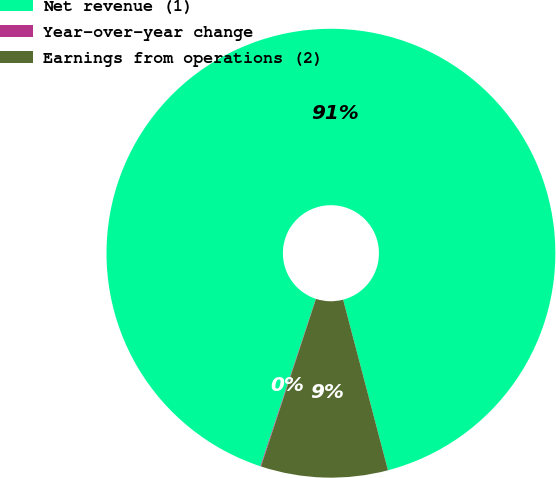Convert chart to OTSL. <chart><loc_0><loc_0><loc_500><loc_500><pie_chart><fcel>Net revenue (1)<fcel>Year-over-year change<fcel>Earnings from operations (2)<nl><fcel>90.82%<fcel>0.05%<fcel>9.13%<nl></chart> 